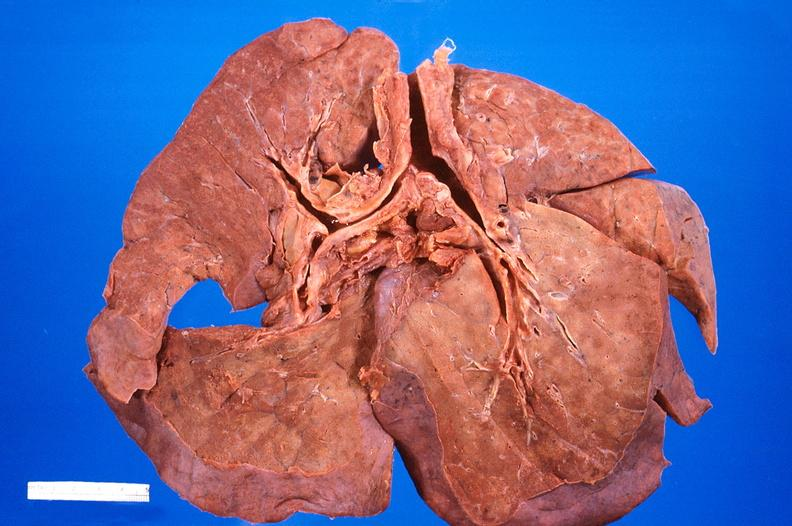where is this?
Answer the question using a single word or phrase. Lung 